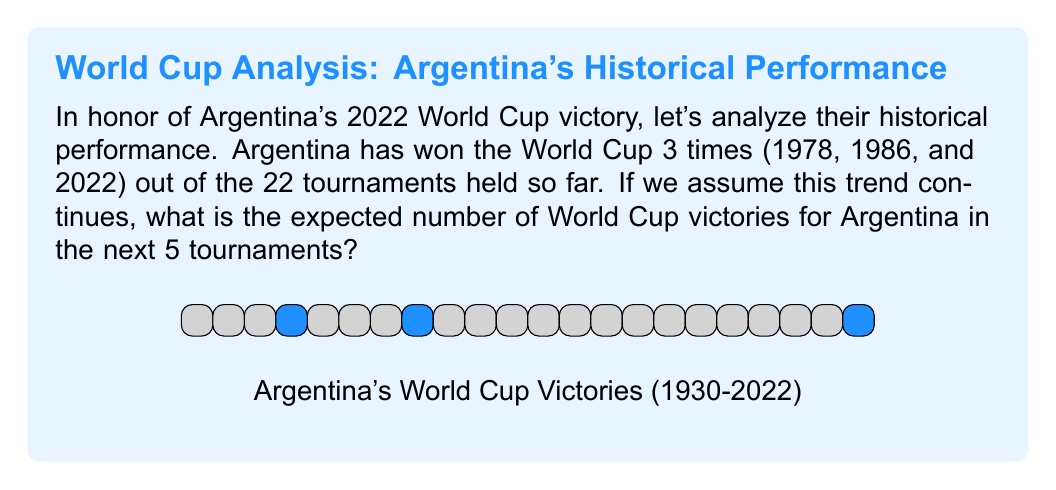Help me with this question. To solve this problem, we need to follow these steps:

1) First, calculate the probability of Argentina winning a single World Cup:
   $p = \frac{\text{Number of wins}}{\text{Total tournaments}} = \frac{3}{22}$

2) The expected number of wins in the next 5 tournaments can be calculated using the formula for expected value:
   $E(X) = np$, where $n$ is the number of trials (tournaments) and $p$ is the probability of success (winning) in each trial.

3) Substituting our values:
   $E(X) = 5 \cdot \frac{3}{22}$

4) Simplifying:
   $E(X) = \frac{15}{22} \approx 0.6818$

Therefore, based on their historical performance, Argentina can expect to win approximately 0.6818 World Cups in the next 5 tournaments.
Answer: $\frac{15}{22}$ or approximately 0.6818 World Cup victories 